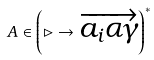Convert formula to latex. <formula><loc_0><loc_0><loc_500><loc_500>A \in \left ( \rhd \to \overrightarrow { a _ { i } \alpha \gamma } \right ) ^ { * }</formula> 